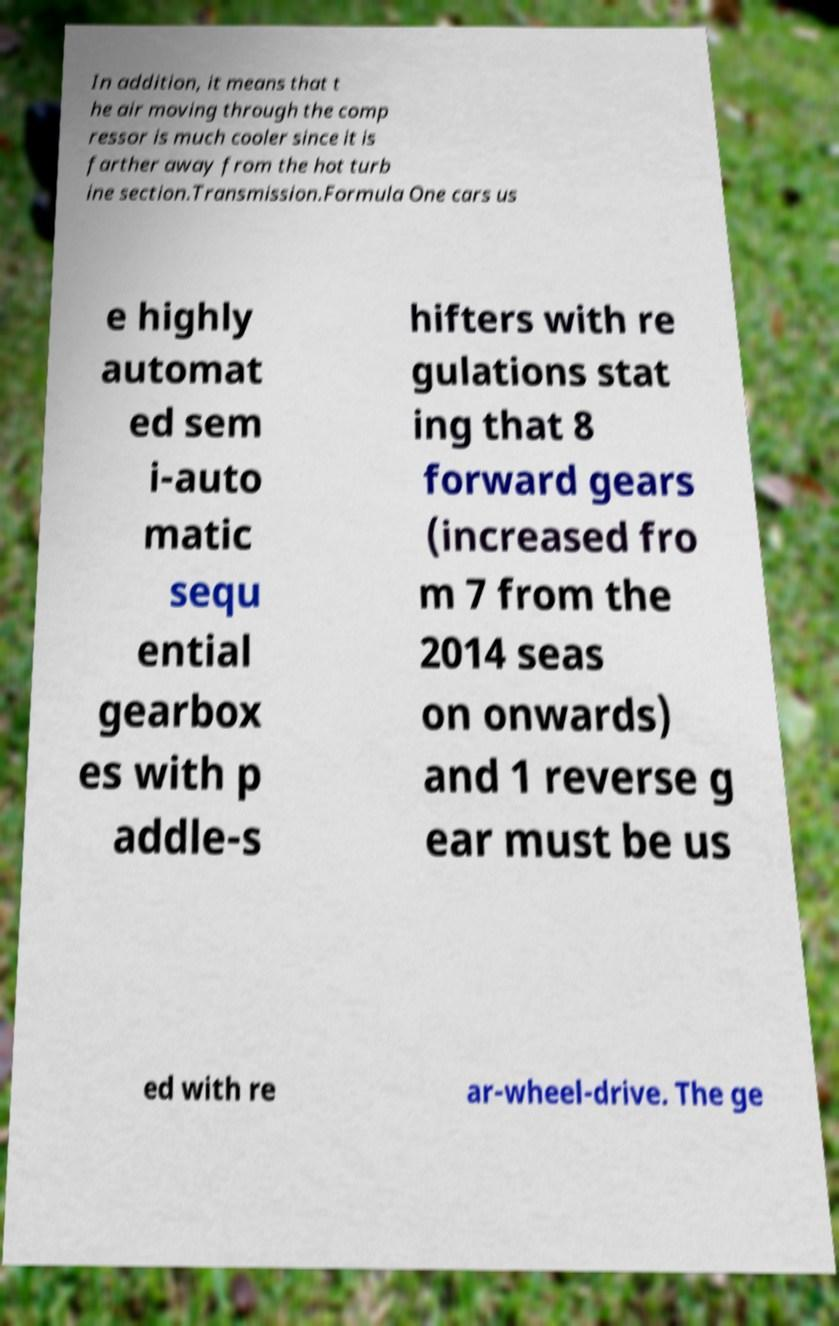Could you extract and type out the text from this image? In addition, it means that t he air moving through the comp ressor is much cooler since it is farther away from the hot turb ine section.Transmission.Formula One cars us e highly automat ed sem i-auto matic sequ ential gearbox es with p addle-s hifters with re gulations stat ing that 8 forward gears (increased fro m 7 from the 2014 seas on onwards) and 1 reverse g ear must be us ed with re ar-wheel-drive. The ge 